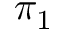Convert formula to latex. <formula><loc_0><loc_0><loc_500><loc_500>\pi _ { 1 }</formula> 